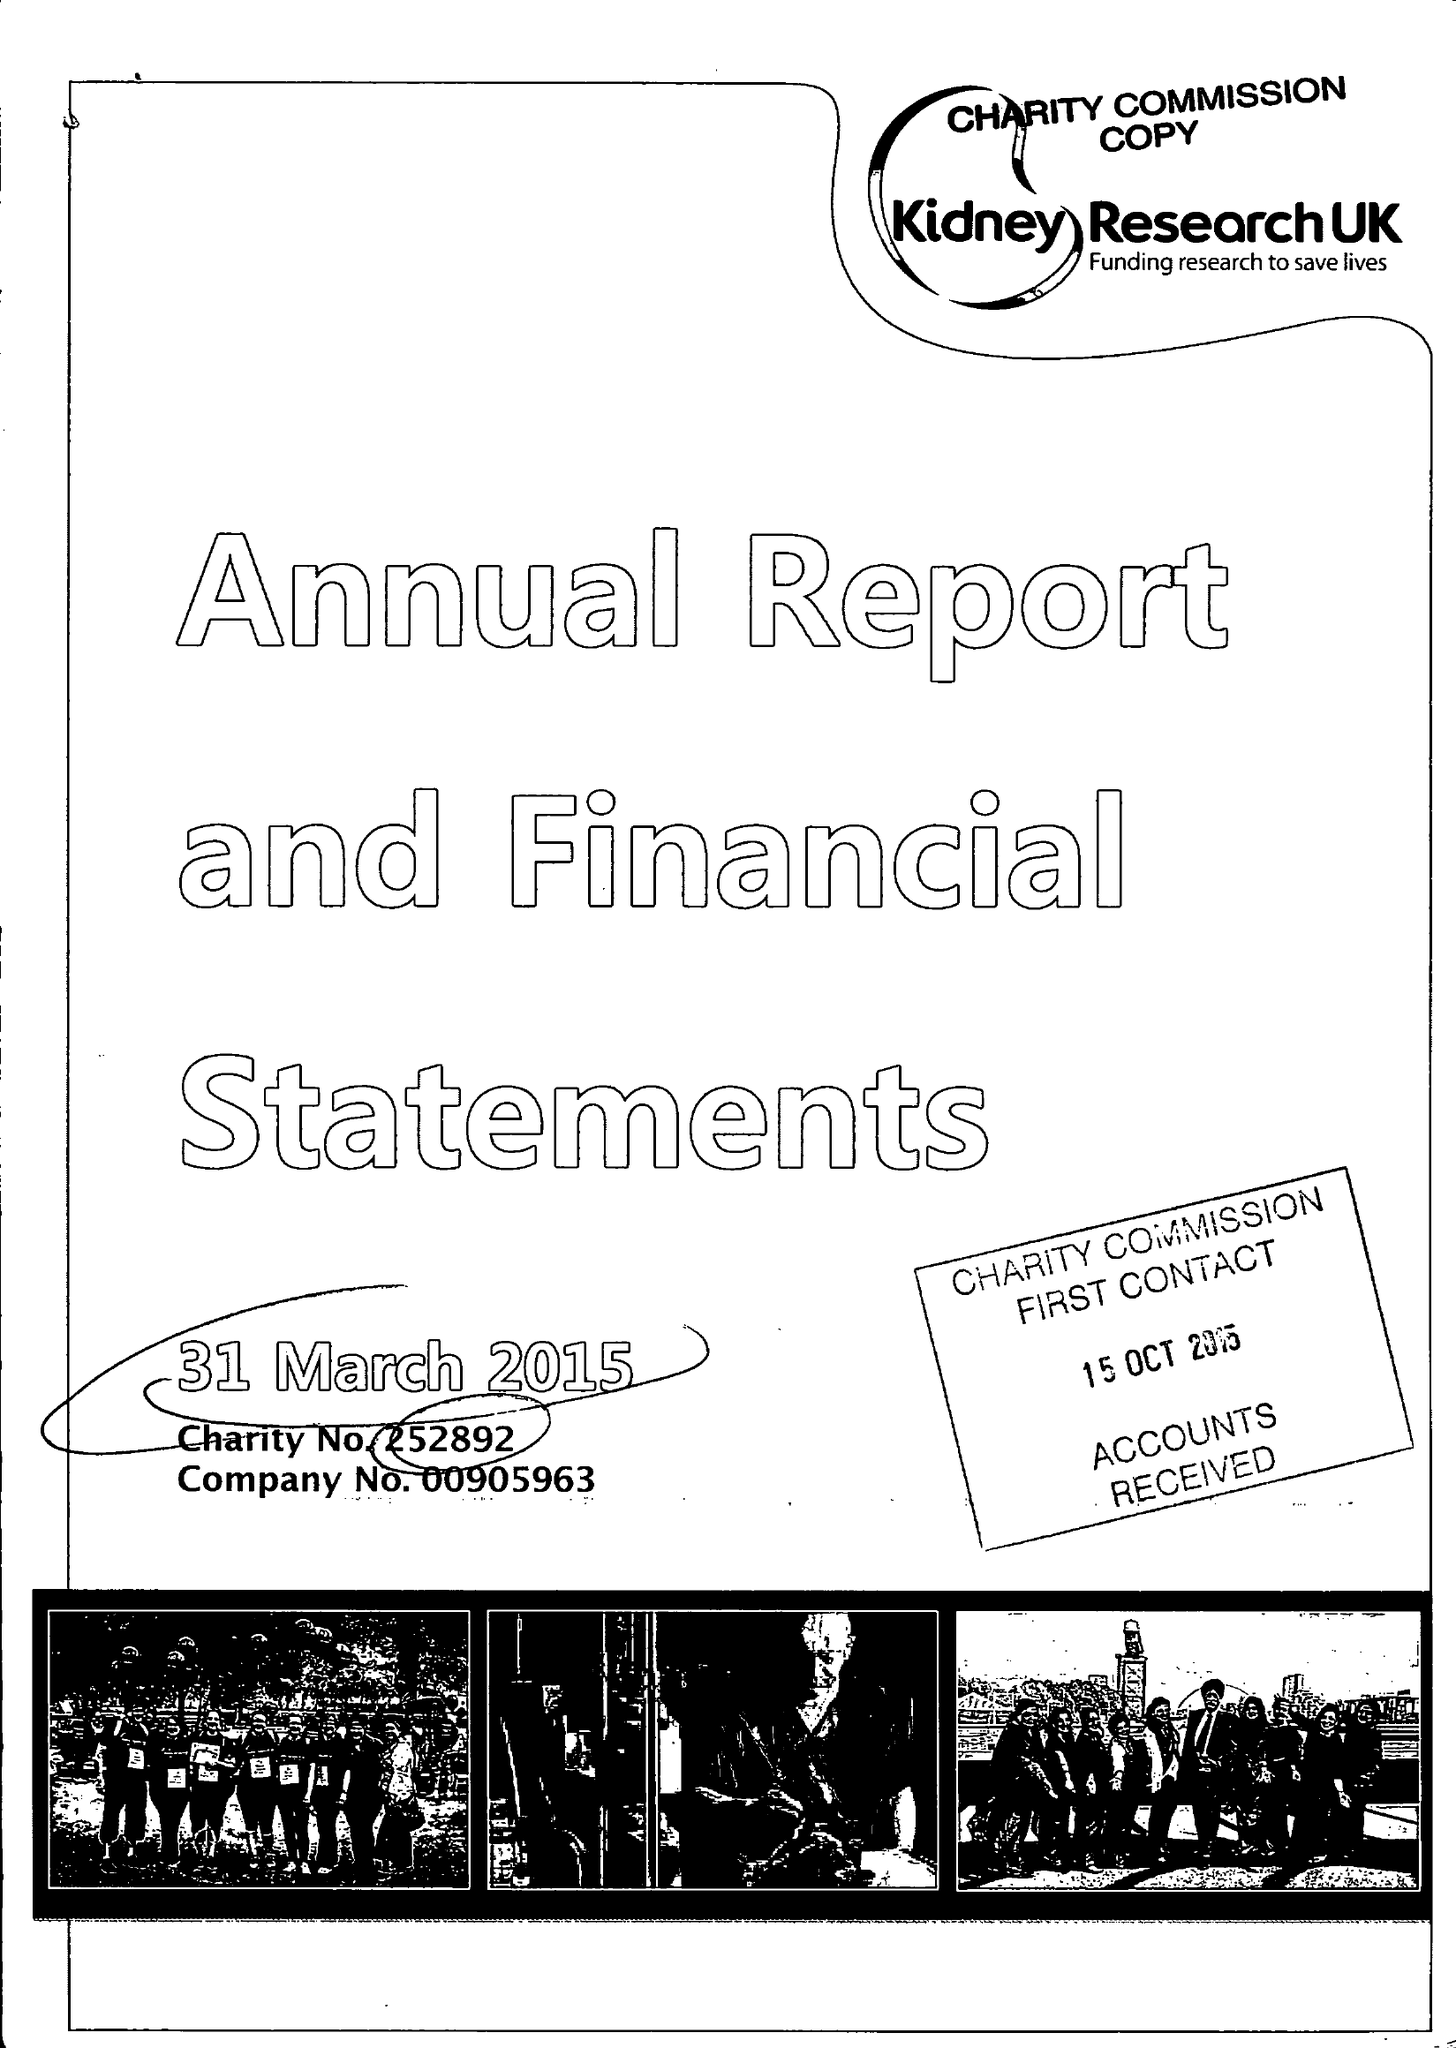What is the value for the address__post_town?
Answer the question using a single word or phrase. PETERBOROUGH 